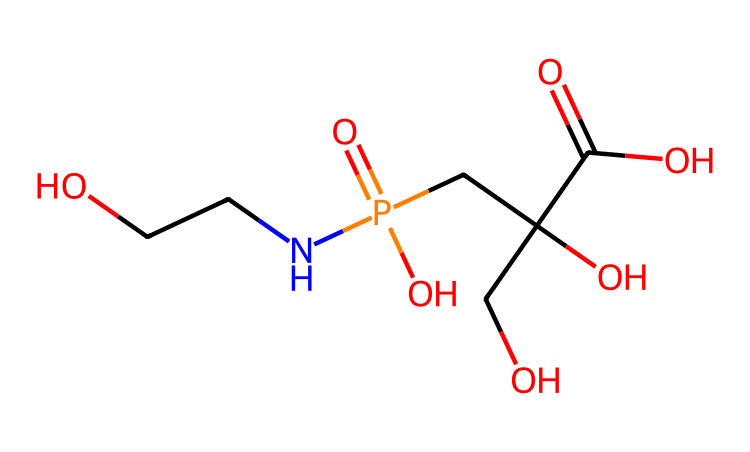What is the molecular formula of glyphosate? To determine the molecular formula, we identify the individual atoms present in the SMILES representation. The components include the following atoms: carbon (C), hydrogen (H), oxygen (O), and phosphorus (P). Counting each, we find there are 9 carbons, 10 hydrogens, 5 oxygens, and 1 phosphorus. Therefore, the molecular formula is C3H8NO5P.
Answer: C3H8NO5P How many total carbon atoms are in glyphosate? Looking at the SMILES representation, we notice that the expression has three carbon atoms in the backbone of the molecule when it is broken down. Thus, the total carbon atoms are counted directly from there.
Answer: 3 Which functional group is present in glyphosate? Observing the chemical structure, we see multiple functional groups. The amino group (NH2) and the phosphonate group (P(=O)(O)O) stand out. Among these, the phosphonate group is critical for glyphosate's herbicidal properties.
Answer: phosphonate Does glyphosate contain nitrogen? In the SMILES representation, there is a section with a nitrogen atom directly present, confirming its presence. This indicates that glyphosate contains nitrogen.
Answer: yes What property does glyphosate primarily exhibit due to its chemical structure? Glyphosate is recognized for its ability to inhibit aromatic amino acid synthesis, which makes it effective as a herbicide. This property is directly related to the presence of its functional groups and overall structure.
Answer: herbicide Is glyphosate considered a non-selective herbicide? Glyphosate affects a wide range of plants, inhibiting growth regardless of the species, which defines it as a non-selective herbicide. This classification comes from its mode of action as observed in various agricultural applications.
Answer: non-selective 